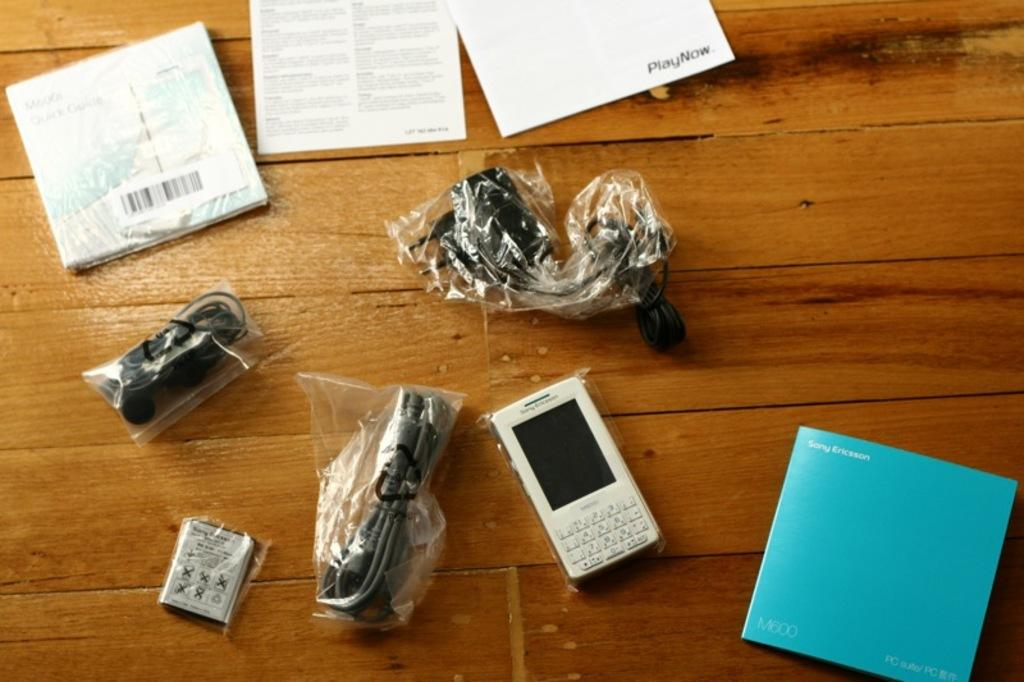Provide a one-sentence caption for the provided image. A Sony Ericsson sits on wood surface with cables still wrapped in plastic and the manual beside it. 